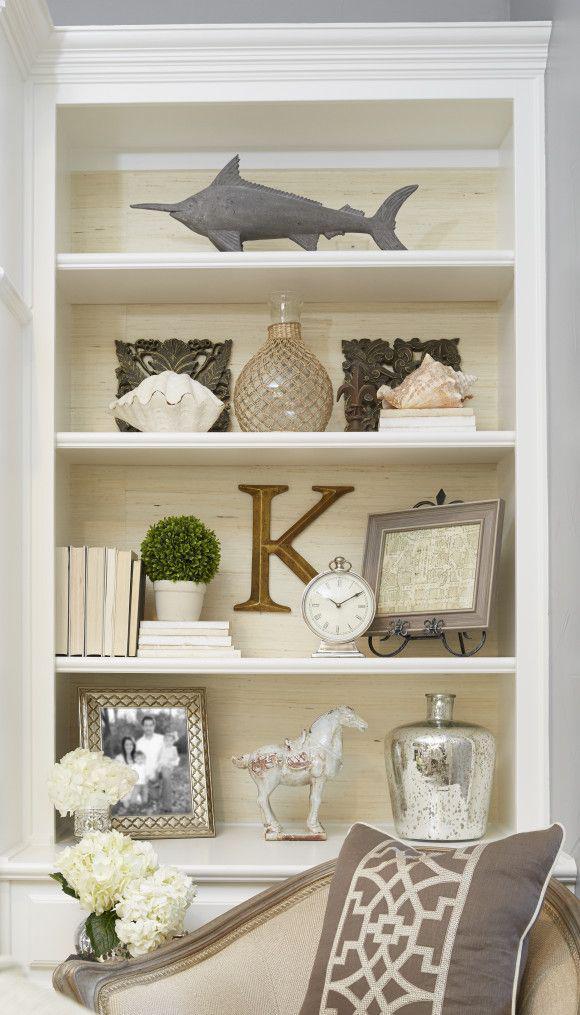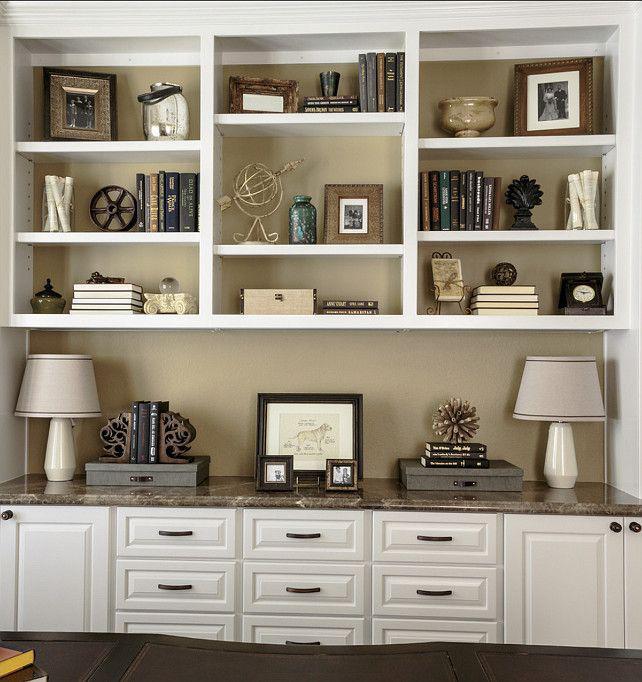The first image is the image on the left, the second image is the image on the right. Analyze the images presented: Is the assertion "There is a clock on the shelf in the image on the left." valid? Answer yes or no. Yes. 